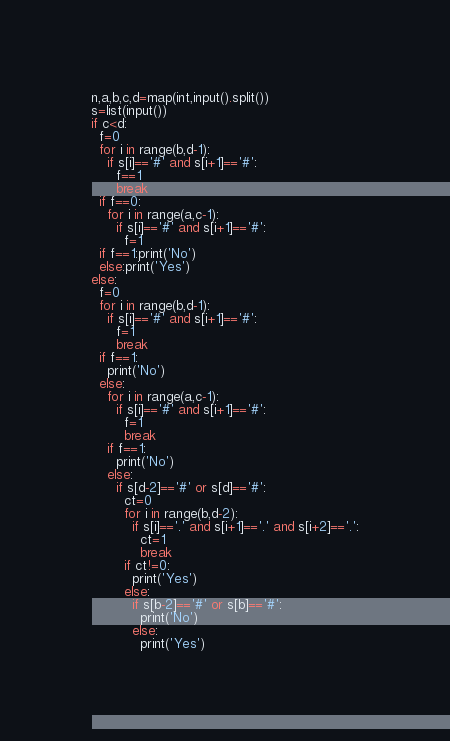<code> <loc_0><loc_0><loc_500><loc_500><_Python_>n,a,b,c,d=map(int,input().split())
s=list(input())
if c<d:
  f=0
  for i in range(b,d-1):
    if s[i]=='#' and s[i+1]=='#':
      f==1
      break
  if f==0:
    for i in range(a,c-1):
      if s[i]=='#' and s[i+1]=='#':
        f=1
  if f==1:print('No')
  else:print('Yes')
else:
  f=0
  for i in range(b,d-1):
    if s[i]=='#' and s[i+1]=='#':
      f=1
      break
  if f==1:
    print('No')
  else:
    for i in range(a,c-1):
      if s[i]=='#' and s[i+1]=='#':
        f=1
        break
    if f==1:
      print('No')
    else:
      if s[d-2]=='#' or s[d]=='#':
        ct=0
        for i in range(b,d-2):
          if s[i]=='.' and s[i+1]=='.' and s[i+2]=='.':
            ct=1
            break
        if ct!=0:
          print('Yes')
        else:
          if s[b-2]=='#' or s[b]=='#':
            print('No')
          else:
            print('Yes')</code> 